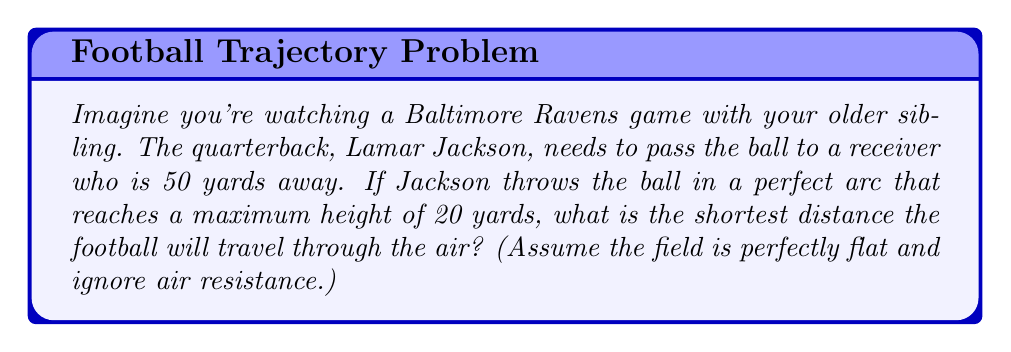Could you help me with this problem? Let's approach this step-by-step:

1) The path of the football forms a parabola. The shortest path between two points on a parabola is not a straight line, but rather the arc of the parabola itself.

2) We can model this situation using a coordinate system where:
   - The x-axis represents the distance along the field
   - The y-axis represents the height of the ball
   - The origin (0,0) is at Lamar Jackson's throwing position
   - The receiver is at (50,0)
   - The highest point of the arc is at (25,20)

3) The general equation of a parabola is:

   $$ y = ax^2 + bx + c $$

4) We can find the values of a, b, and c using the three points we know:
   (0,0), (25,20), and (50,0)

5) Substituting these points into the equation:

   $$ 0 = a(0)^2 + b(0) + c $$
   $$ 20 = a(25)^2 + b(25) + c $$
   $$ 0 = a(50)^2 + b(50) + c $$

6) From the first equation, we can see that $c = 0$

7) Subtracting the third equation from the second:

   $$ 20 = a(25^2 - 50^2) + b(25 - 50) $$
   $$ 20 = -1875a - 25b $$

8) From the second equation:

   $$ 20 = 625a + 25b $$

9) Solving these simultaneously:

   $$ a = -\frac{32}{2500} = -0.0128 $$
   $$ b = 0.64 $$

10) So the equation of the parabola is:

    $$ y = -0.0128x^2 + 0.64x $$

11) To find the length of the arc, we use the arc length formula:

    $$ L = \int_{0}^{50} \sqrt{1 + \left(\frac{dy}{dx}\right)^2} dx $$

    where $\frac{dy}{dx} = -0.0256x + 0.64$

12) This integral doesn't have a simple algebraic solution, so we need to use numerical integration methods to solve it.
Answer: Using numerical integration, the shortest distance the football will travel through the air is approximately 50.67 yards. 